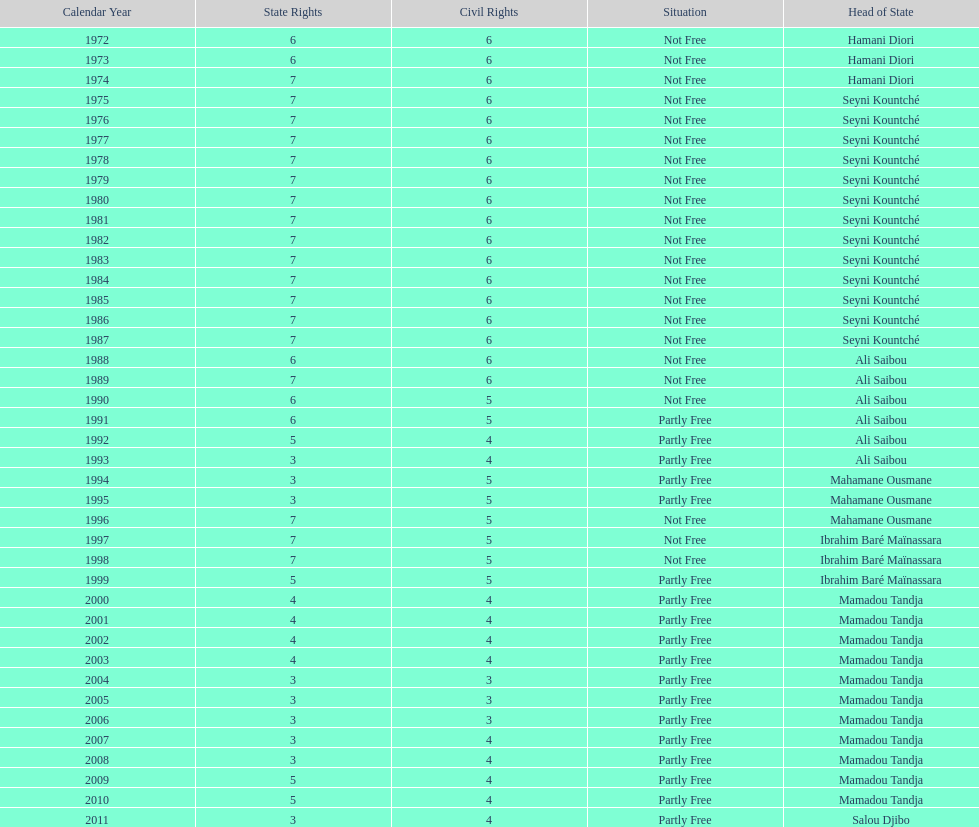How many times was the political rights listed as seven? 18. 